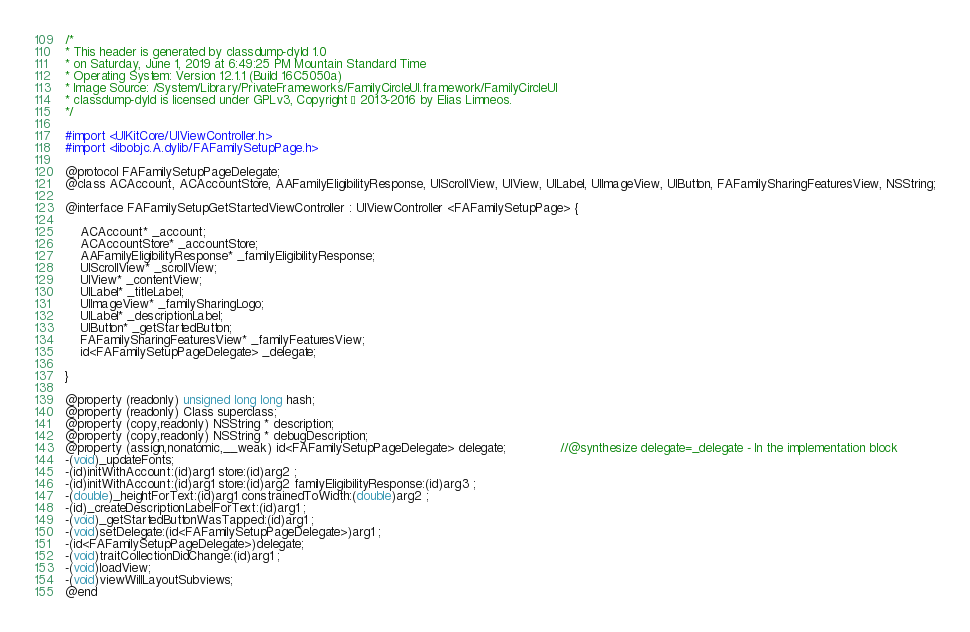Convert code to text. <code><loc_0><loc_0><loc_500><loc_500><_C_>/*
* This header is generated by classdump-dyld 1.0
* on Saturday, June 1, 2019 at 6:49:25 PM Mountain Standard Time
* Operating System: Version 12.1.1 (Build 16C5050a)
* Image Source: /System/Library/PrivateFrameworks/FamilyCircleUI.framework/FamilyCircleUI
* classdump-dyld is licensed under GPLv3, Copyright © 2013-2016 by Elias Limneos.
*/

#import <UIKitCore/UIViewController.h>
#import <libobjc.A.dylib/FAFamilySetupPage.h>

@protocol FAFamilySetupPageDelegate;
@class ACAccount, ACAccountStore, AAFamilyEligibilityResponse, UIScrollView, UIView, UILabel, UIImageView, UIButton, FAFamilySharingFeaturesView, NSString;

@interface FAFamilySetupGetStartedViewController : UIViewController <FAFamilySetupPage> {

	ACAccount* _account;
	ACAccountStore* _accountStore;
	AAFamilyEligibilityResponse* _familyEligibilityResponse;
	UIScrollView* _scrollView;
	UIView* _contentView;
	UILabel* _titleLabel;
	UIImageView* _familySharingLogo;
	UILabel* _descriptionLabel;
	UIButton* _getStartedButton;
	FAFamilySharingFeaturesView* _familyFeaturesView;
	id<FAFamilySetupPageDelegate> _delegate;

}

@property (readonly) unsigned long long hash; 
@property (readonly) Class superclass; 
@property (copy,readonly) NSString * description; 
@property (copy,readonly) NSString * debugDescription; 
@property (assign,nonatomic,__weak) id<FAFamilySetupPageDelegate> delegate;              //@synthesize delegate=_delegate - In the implementation block
-(void)_updateFonts;
-(id)initWithAccount:(id)arg1 store:(id)arg2 ;
-(id)initWithAccount:(id)arg1 store:(id)arg2 familyEligibilityResponse:(id)arg3 ;
-(double)_heightForText:(id)arg1 constrainedToWidth:(double)arg2 ;
-(id)_createDescriptionLabelForText:(id)arg1 ;
-(void)_getStartedButtonWasTapped:(id)arg1 ;
-(void)setDelegate:(id<FAFamilySetupPageDelegate>)arg1 ;
-(id<FAFamilySetupPageDelegate>)delegate;
-(void)traitCollectionDidChange:(id)arg1 ;
-(void)loadView;
-(void)viewWillLayoutSubviews;
@end

</code> 